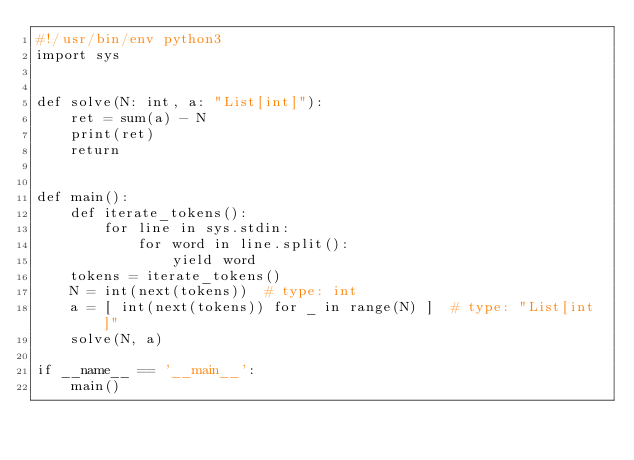<code> <loc_0><loc_0><loc_500><loc_500><_Python_>#!/usr/bin/env python3
import sys


def solve(N: int, a: "List[int]"):
    ret = sum(a) - N
    print(ret)
    return


def main():
    def iterate_tokens():
        for line in sys.stdin:
            for word in line.split():
                yield word
    tokens = iterate_tokens()
    N = int(next(tokens))  # type: int
    a = [ int(next(tokens)) for _ in range(N) ]  # type: "List[int]"
    solve(N, a)

if __name__ == '__main__':
    main()
</code> 